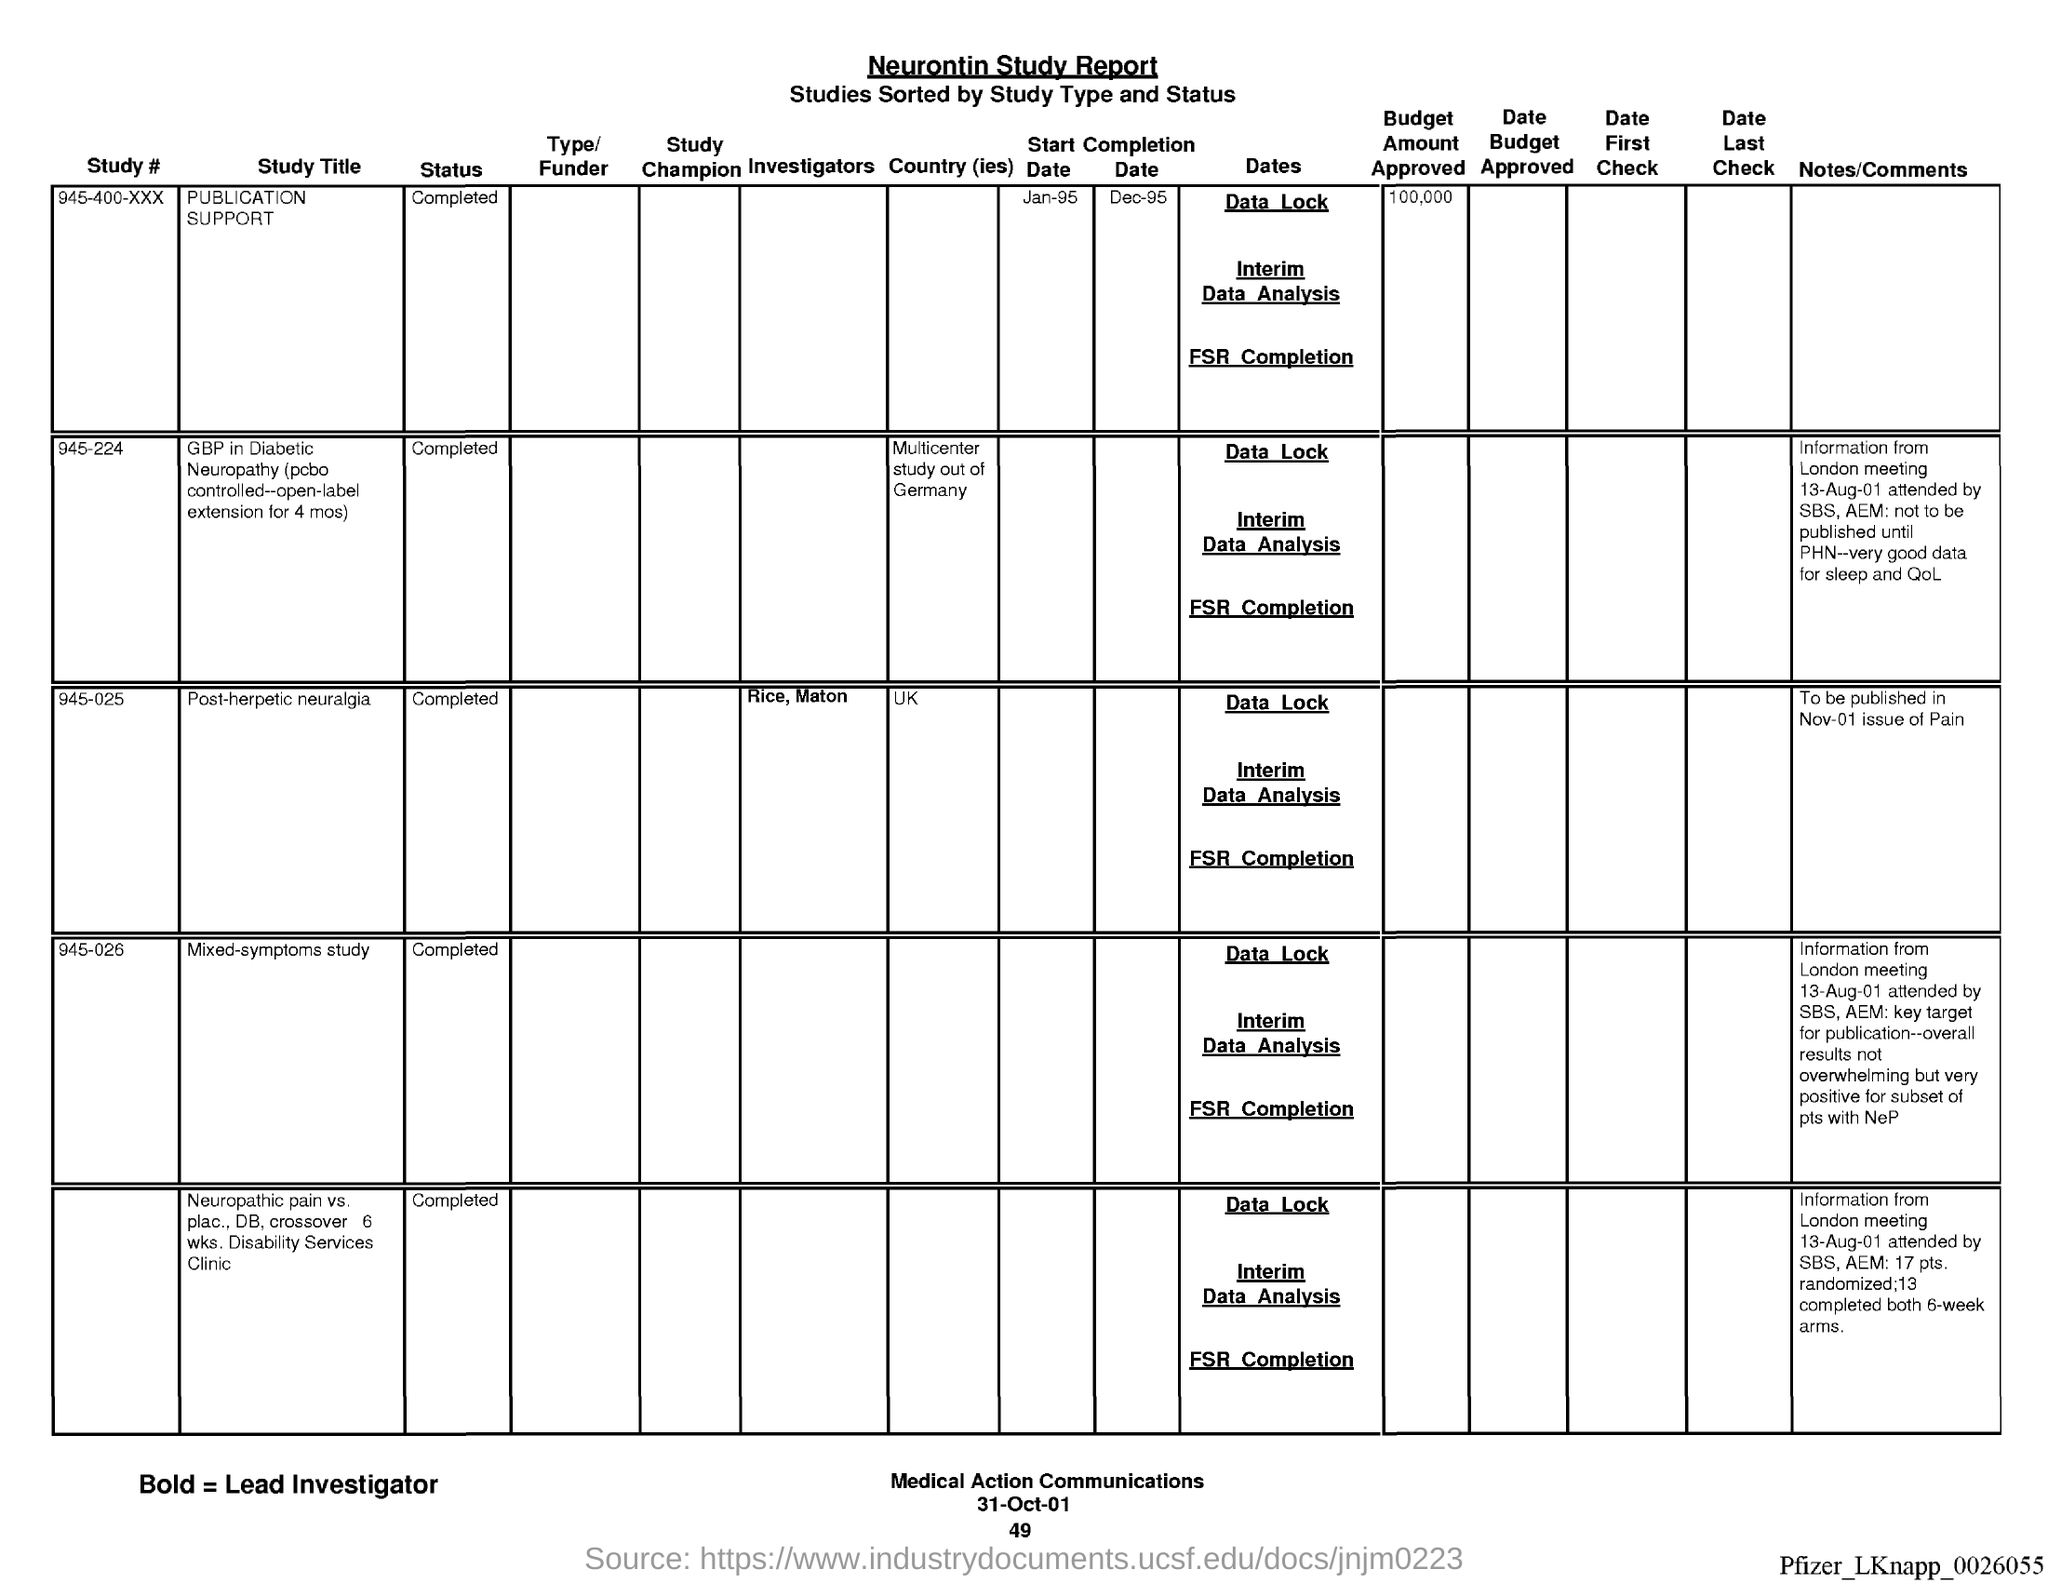What is the date at bottom of the page?
Your answer should be compact. 31-Oct-01. What is the name of the report ?
Ensure brevity in your answer.  Neurontin Study Report. What is the page number below date?
Ensure brevity in your answer.  49. 